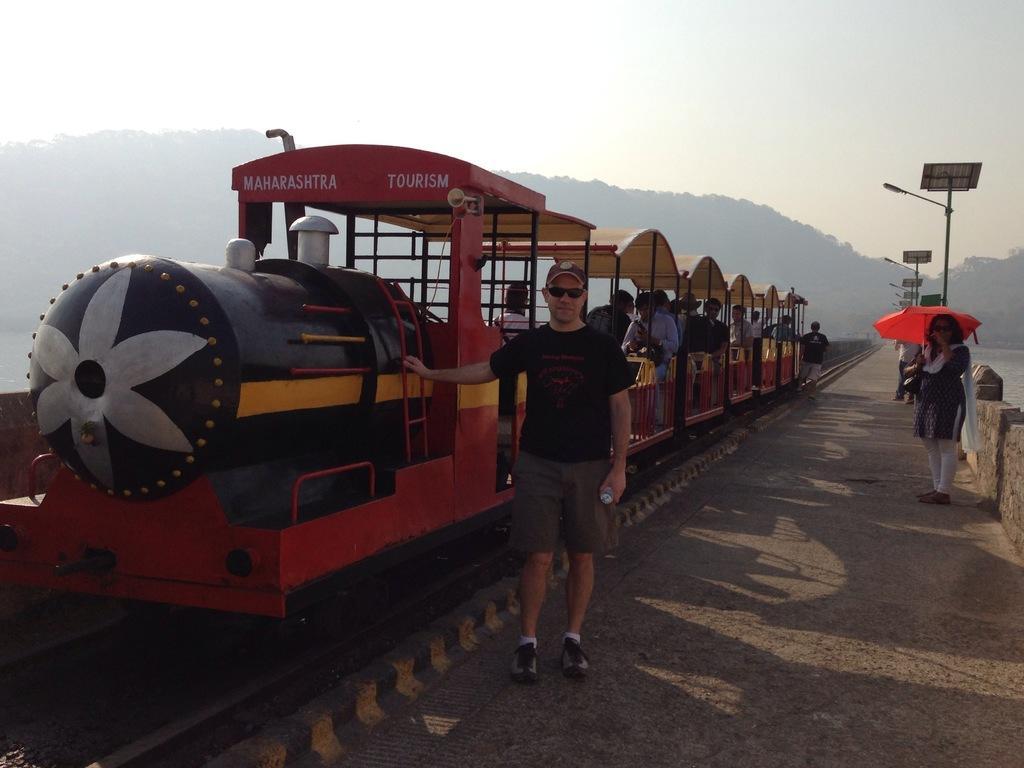In one or two sentences, can you explain what this image depicts? This image is taken outdoors. At the top of the image there is a sky with clouds. In the background there are many trees. In the middle of the image there is a train moving on the track. A few people are sitting in the train. A man is standing on the road. On the right side of the image there are many poles with street lights and there are many boards with text on them. A few are standing on the road and a woman is holding an umbrella in her hands. 